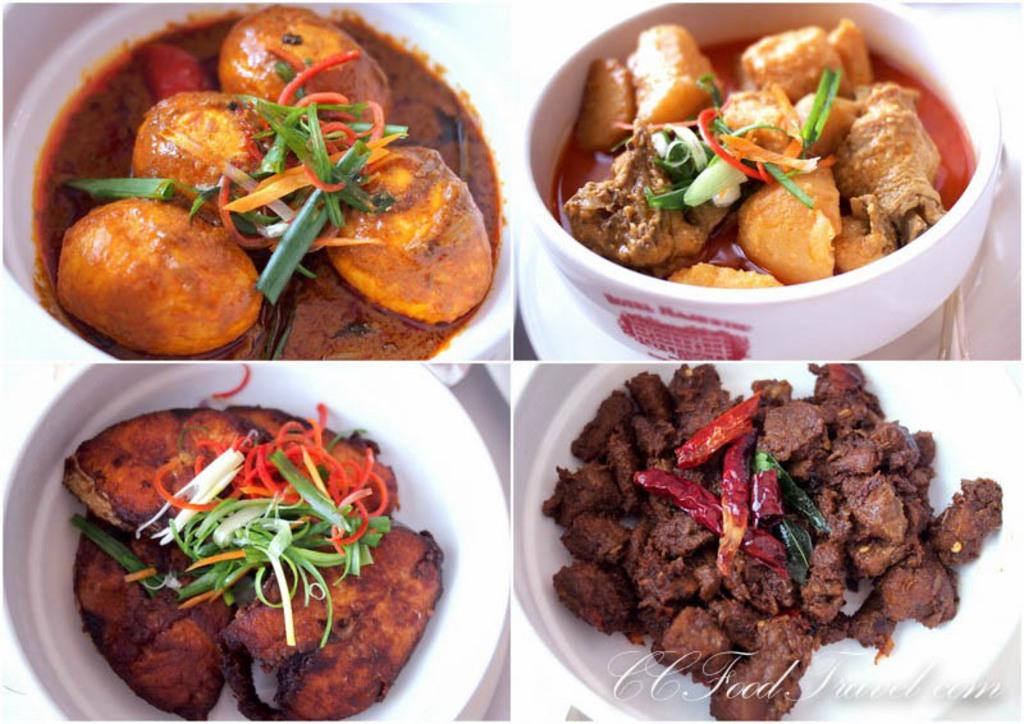What type of image is being described? The image is a collage. What can be found within the collage? There are food items in bowls in the image. Is there any additional information or branding on the image? Yes, there is a watermark on the image. What type of spark can be seen coming from the stick in the image? There is no stick or spark present in the image. What degree of difficulty is associated with the image? The image does not have an associated degree of difficulty. 